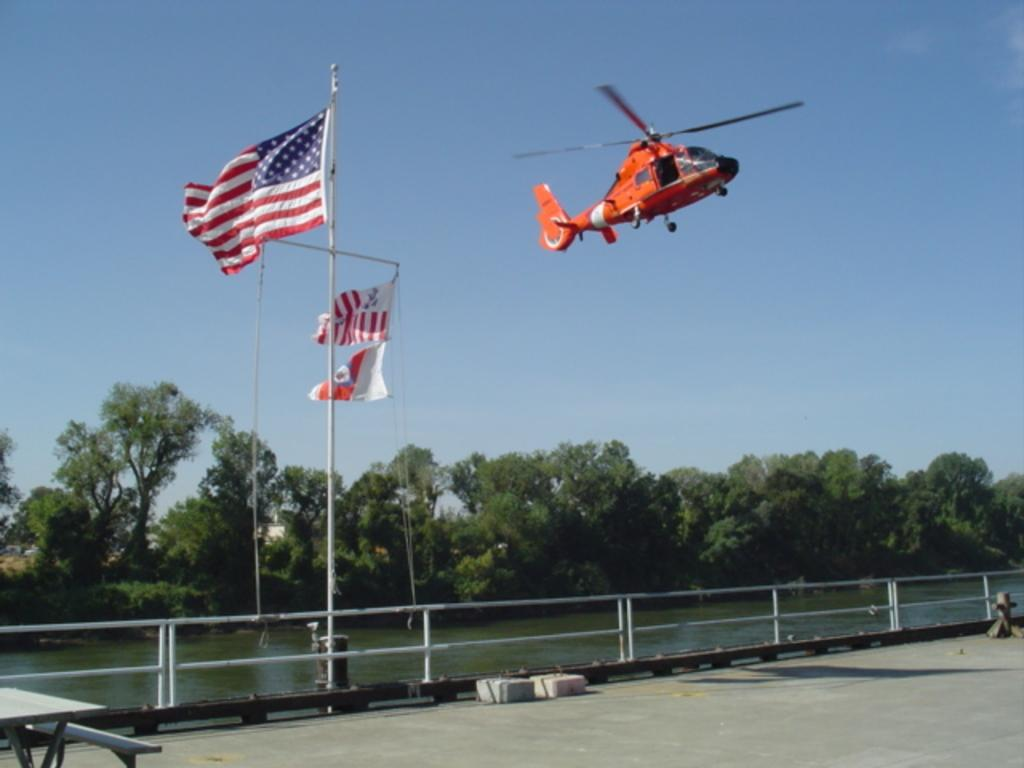What is flying in the sky in the image? There is a helicopter flying in the sky in the image. What can be seen besides the helicopter in the image? There are flags, trees, water, a railing, a table, a bench, and stones on the ground visible in the image. Where is the goat standing in the image? There is no goat present in the image. What type of frame is used to hold the image? The question about the frame is not relevant to the image itself, as it refers to the physical object holding the image rather than the image itself. 